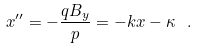Convert formula to latex. <formula><loc_0><loc_0><loc_500><loc_500>x ^ { \prime \prime } = - \frac { q B _ { y } } { p } = - k x - \kappa \ .</formula> 